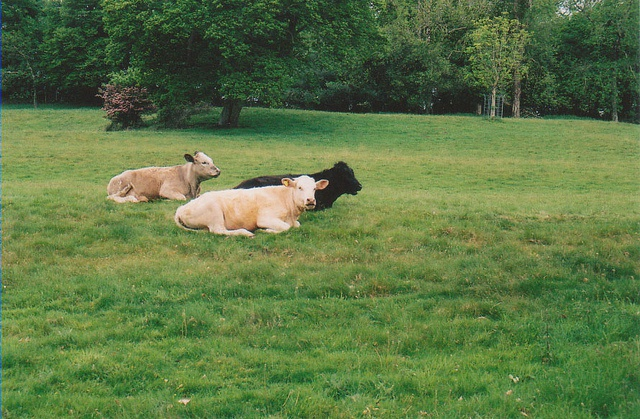Describe the objects in this image and their specific colors. I can see cow in gray, tan, and lightgray tones, cow in gray and tan tones, and cow in gray, black, olive, and darkgreen tones in this image. 